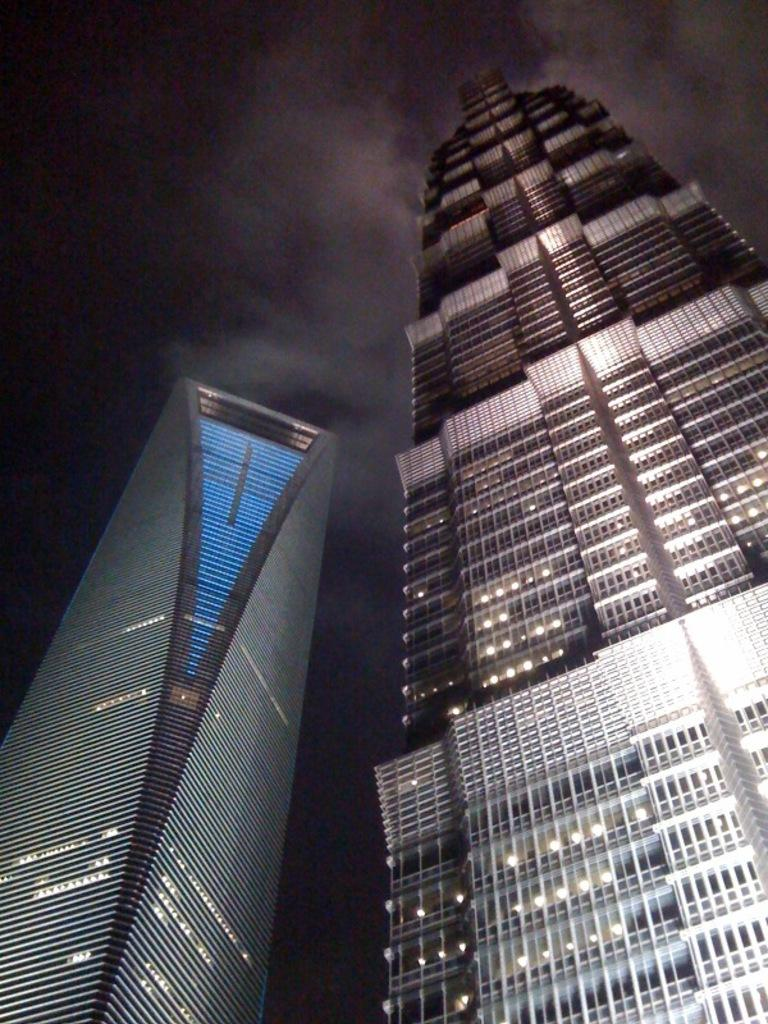What structures are the main subjects in the image? There are two tall buildings in the image. What is visible in the background of the image? The sky is visible in the image. How many cables can be seen connecting the two tall buildings in the image? There are no cables visible connecting the two tall buildings in the image. Are the two tall buildings in the image sisters? The image does not provide information about the relationship between the two tall buildings, so it cannot be determined if they are sisters. Can you tell me how many daughters are present in the image? There are no people, let alone daughters, present in the image; it features two tall buildings and the sky. 